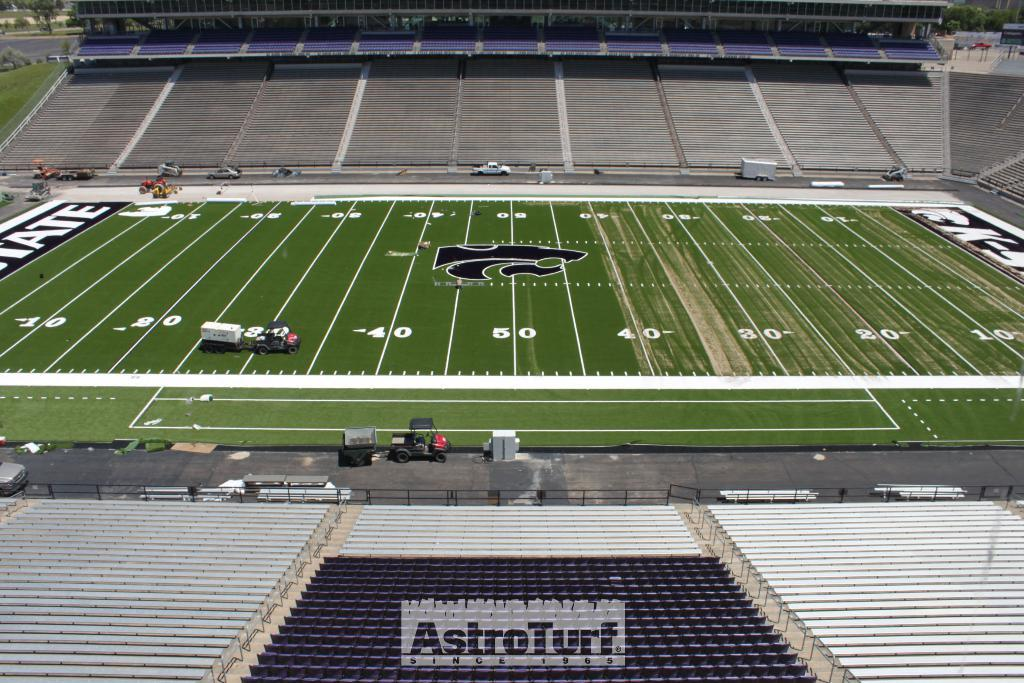Provide a one-sentence caption for the provided image. an Astro Turf since 1995 logo can be seen on the seats in the stadium. 